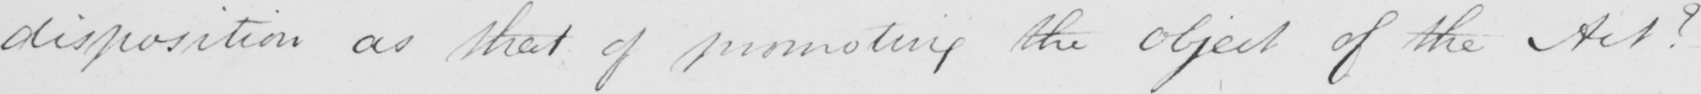What does this handwritten line say? disposition as that of promoting the object of the Act ?  - 